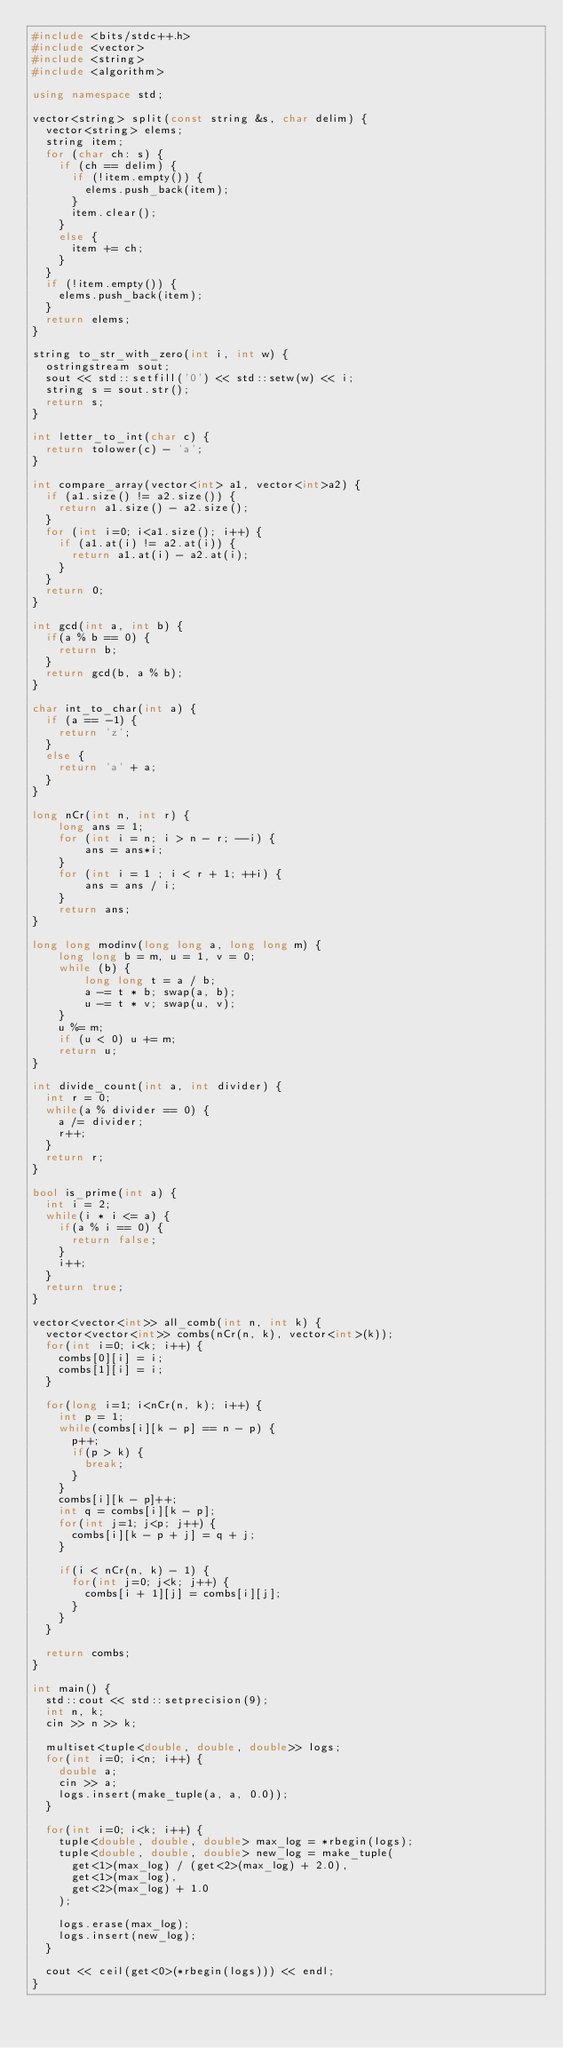Convert code to text. <code><loc_0><loc_0><loc_500><loc_500><_C++_>#include <bits/stdc++.h>
#include <vector>
#include <string>
#include <algorithm>

using namespace std;

vector<string> split(const string &s, char delim) {
  vector<string> elems;
  string item;
  for (char ch: s) {
    if (ch == delim) {
      if (!item.empty()) {
        elems.push_back(item);
      }
      item.clear();
    }
    else {
      item += ch;
    }
  }
  if (!item.empty()) {
    elems.push_back(item);
  }
  return elems;
}

string to_str_with_zero(int i, int w) {
  ostringstream sout;
  sout << std::setfill('0') << std::setw(w) << i;
  string s = sout.str();
  return s;
}

int letter_to_int(char c) {
  return tolower(c) - 'a';
}

int compare_array(vector<int> a1, vector<int>a2) {
  if (a1.size() != a2.size()) {
    return a1.size() - a2.size();
  }
  for (int i=0; i<a1.size(); i++) {
    if (a1.at(i) != a2.at(i)) {
      return a1.at(i) - a2.at(i);
    }
  }
  return 0;
}

int gcd(int a, int b) {
  if(a % b == 0) {
    return b;
  }
  return gcd(b, a % b);
}

char int_to_char(int a) {
  if (a == -1) {
    return 'z';
  }
  else {
    return 'a' + a;
  }
}

long nCr(int n, int r) {
    long ans = 1;
    for (int i = n; i > n - r; --i) {
        ans = ans*i;
    }
    for (int i = 1 ; i < r + 1; ++i) {
        ans = ans / i;
    }
    return ans;
}

long long modinv(long long a, long long m) {
    long long b = m, u = 1, v = 0;
    while (b) {
        long long t = a / b;
        a -= t * b; swap(a, b);
        u -= t * v; swap(u, v);
    }
    u %= m; 
    if (u < 0) u += m;
    return u;
}

int divide_count(int a, int divider) {
  int r = 0;
  while(a % divider == 0) {
    a /= divider;
    r++;
  }
  return r;
}

bool is_prime(int a) {
  int i = 2;
  while(i * i <= a) {
    if(a % i == 0) {
      return false;
    }
    i++;
  }
  return true;
}

vector<vector<int>> all_comb(int n, int k) {
  vector<vector<int>> combs(nCr(n, k), vector<int>(k));
  for(int i=0; i<k; i++) {
    combs[0][i] = i;
    combs[1][i] = i;
  }
  
  for(long i=1; i<nCr(n, k); i++) {
    int p = 1;
    while(combs[i][k - p] == n - p) {
      p++;
      if(p > k) {
        break;
      }
    }
    combs[i][k - p]++;
    int q = combs[i][k - p];
    for(int j=1; j<p; j++) {
      combs[i][k - p + j] = q + j;
    }

    if(i < nCr(n, k) - 1) {
      for(int j=0; j<k; j++) {
        combs[i + 1][j] = combs[i][j];
      }
    }
  }

  return combs;
}

int main() {
  std::cout << std::setprecision(9);
  int n, k;
  cin >> n >> k;

  multiset<tuple<double, double, double>> logs;
  for(int i=0; i<n; i++) {
    double a;
    cin >> a;
    logs.insert(make_tuple(a, a, 0.0));
  }

  for(int i=0; i<k; i++) {
    tuple<double, double, double> max_log = *rbegin(logs);
    tuple<double, double, double> new_log = make_tuple(
      get<1>(max_log) / (get<2>(max_log) + 2.0),
      get<1>(max_log),
      get<2>(max_log) + 1.0
    );

    logs.erase(max_log);
    logs.insert(new_log);
  }

  cout << ceil(get<0>(*rbegin(logs))) << endl;
}</code> 